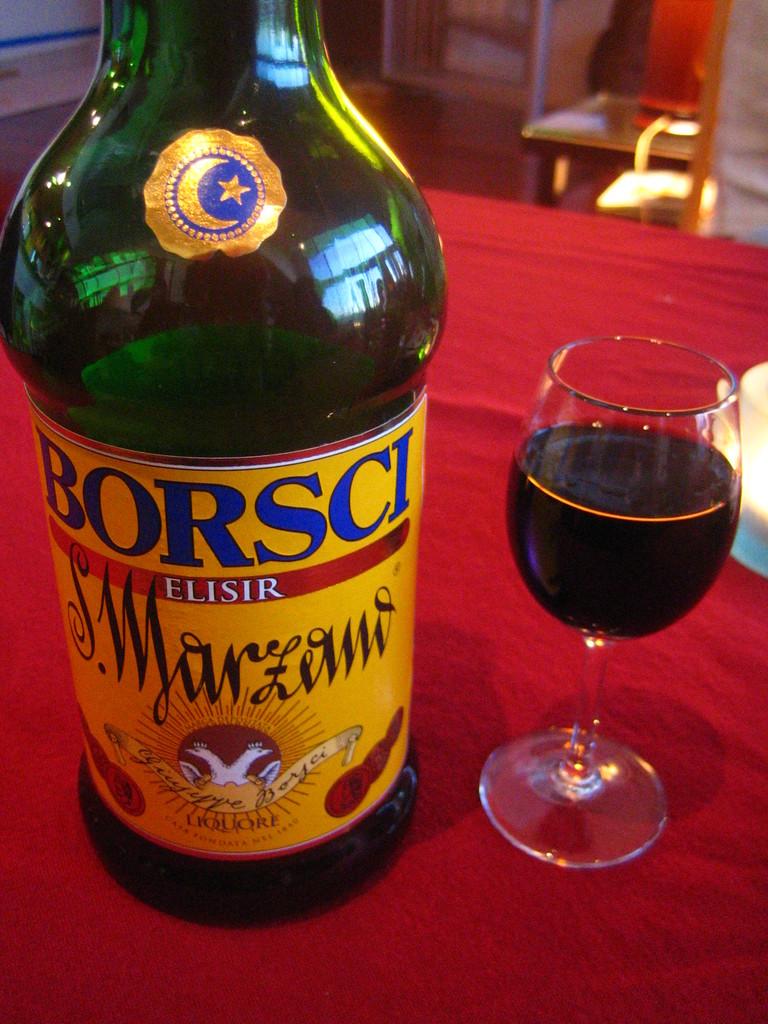What brand made this liquor?
Give a very brief answer. Borsci. What kind of alcohol is this?
Offer a very short reply. Borsci. 